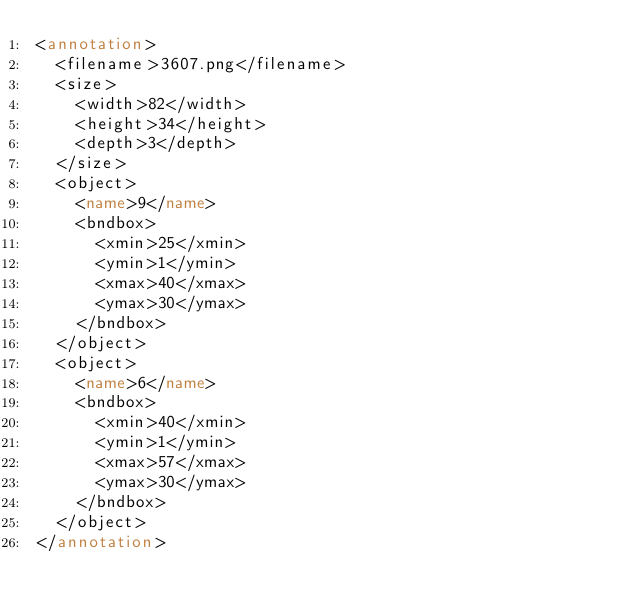Convert code to text. <code><loc_0><loc_0><loc_500><loc_500><_XML_><annotation>
  <filename>3607.png</filename>
  <size>
    <width>82</width>
    <height>34</height>
    <depth>3</depth>
  </size>
  <object>
    <name>9</name>
    <bndbox>
      <xmin>25</xmin>
      <ymin>1</ymin>
      <xmax>40</xmax>
      <ymax>30</ymax>
    </bndbox>
  </object>
  <object>
    <name>6</name>
    <bndbox>
      <xmin>40</xmin>
      <ymin>1</ymin>
      <xmax>57</xmax>
      <ymax>30</ymax>
    </bndbox>
  </object>
</annotation>
</code> 